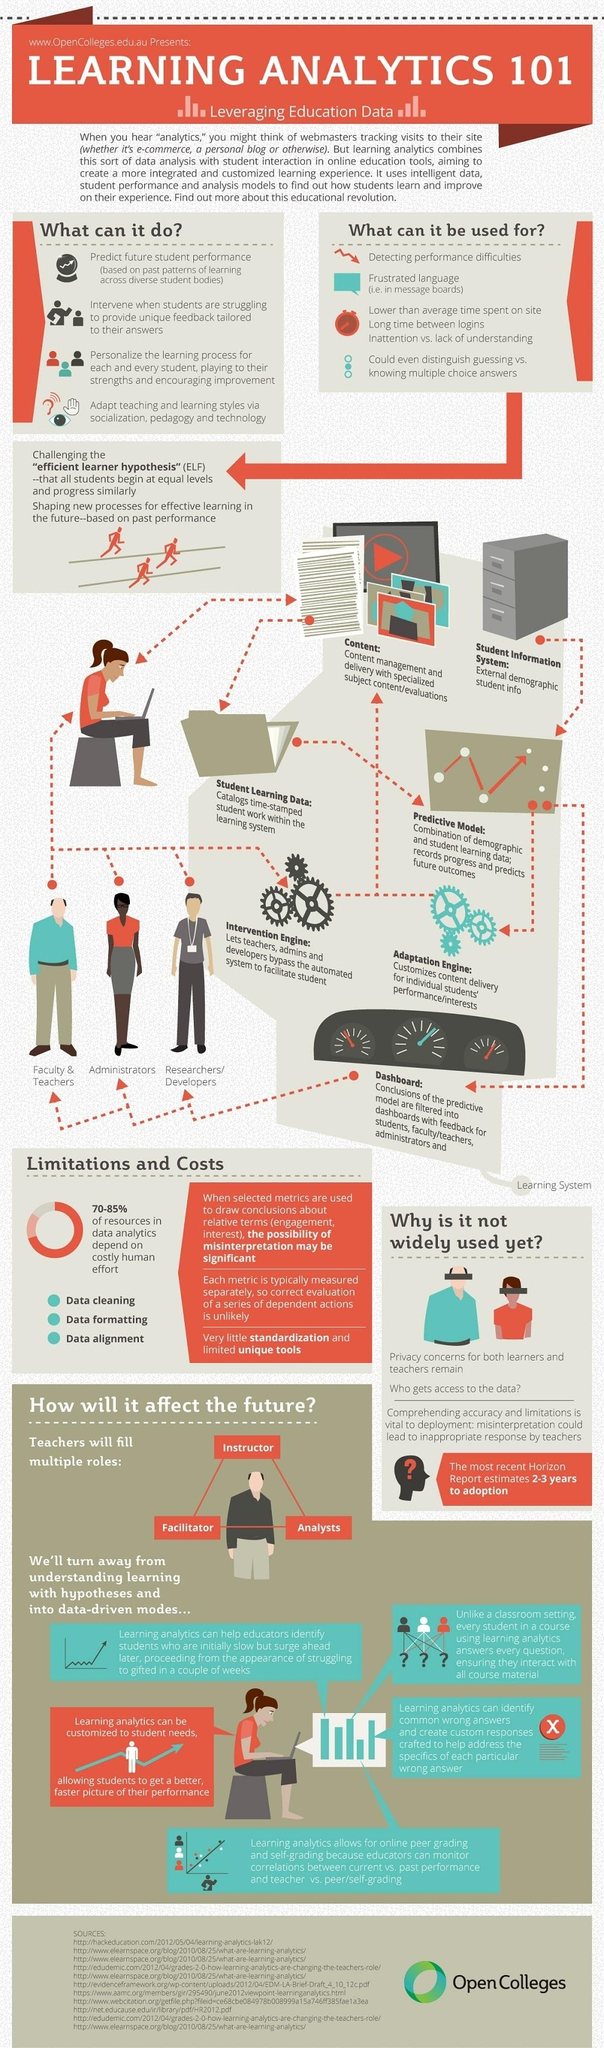Identify some key points in this picture. Teachers assume various roles, such as being instructors, facilitators, and analysts, to support students' learning and development. The way in which data is arranged and accessed in computer memory is through data alignment, which refers to the placement of data within memory to optimize the efficiency of data processing and access. 